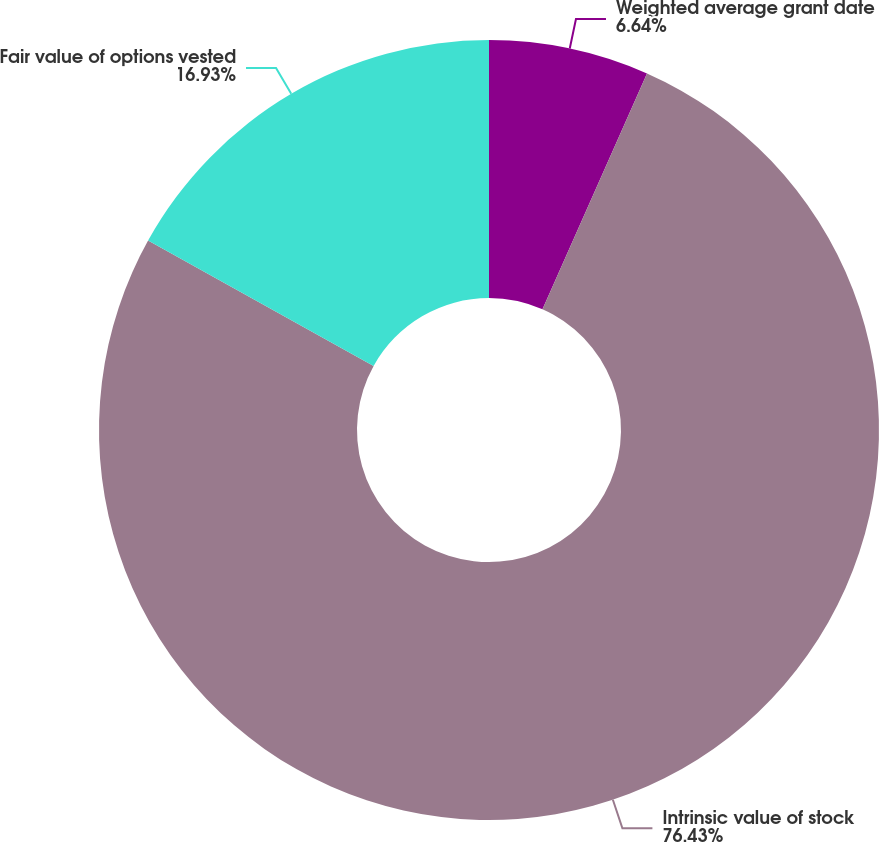Convert chart. <chart><loc_0><loc_0><loc_500><loc_500><pie_chart><fcel>Weighted average grant date<fcel>Intrinsic value of stock<fcel>Fair value of options vested<nl><fcel>6.64%<fcel>76.44%<fcel>16.93%<nl></chart> 